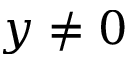Convert formula to latex. <formula><loc_0><loc_0><loc_500><loc_500>y \neq 0</formula> 